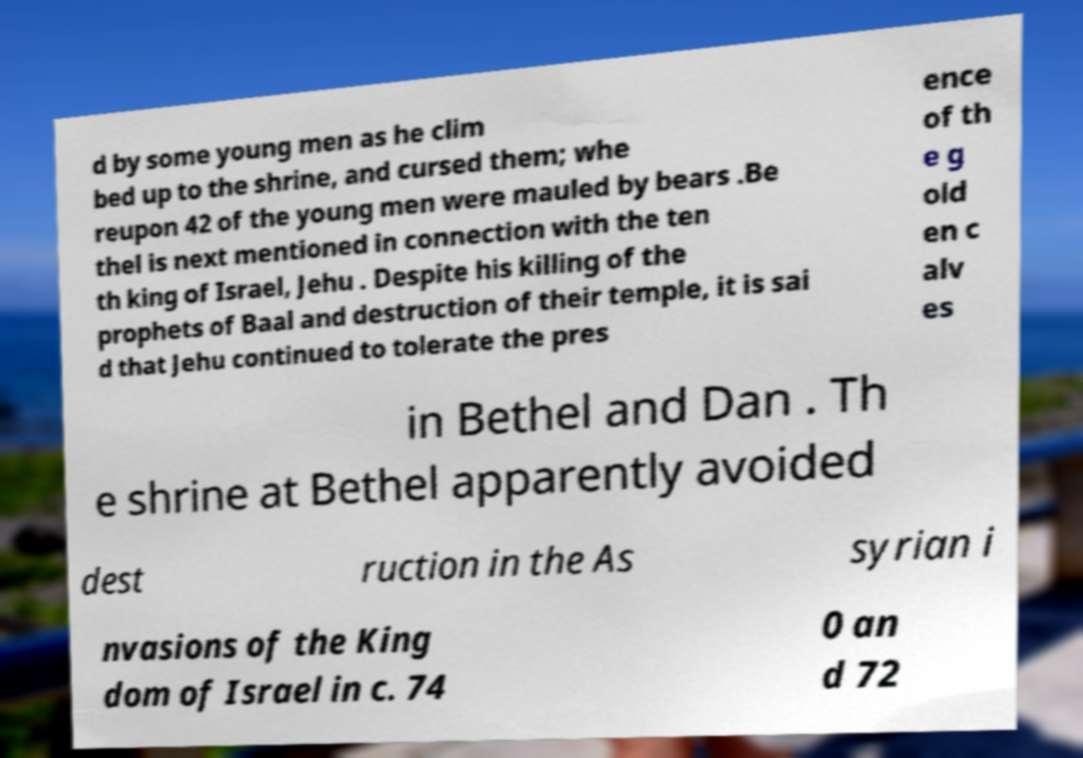What messages or text are displayed in this image? I need them in a readable, typed format. d by some young men as he clim bed up to the shrine, and cursed them; whe reupon 42 of the young men were mauled by bears .Be thel is next mentioned in connection with the ten th king of Israel, Jehu . Despite his killing of the prophets of Baal and destruction of their temple, it is sai d that Jehu continued to tolerate the pres ence of th e g old en c alv es in Bethel and Dan . Th e shrine at Bethel apparently avoided dest ruction in the As syrian i nvasions of the King dom of Israel in c. 74 0 an d 72 